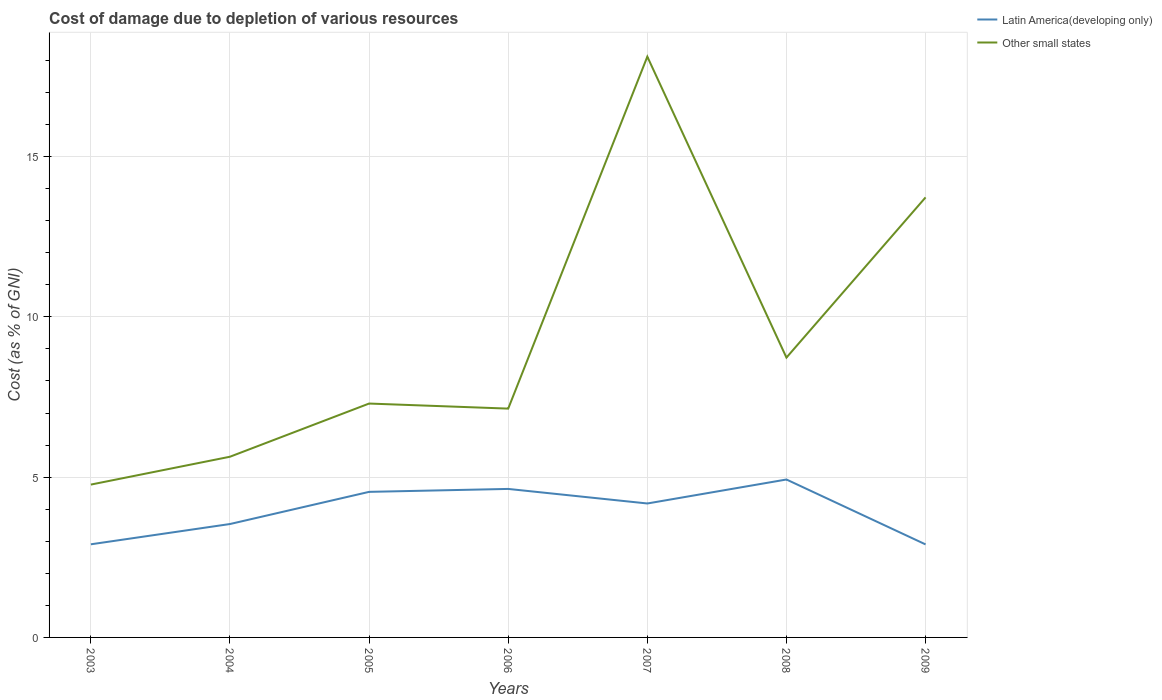Does the line corresponding to Latin America(developing only) intersect with the line corresponding to Other small states?
Make the answer very short. No. Across all years, what is the maximum cost of damage caused due to the depletion of various resources in Other small states?
Offer a very short reply. 4.77. What is the total cost of damage caused due to the depletion of various resources in Latin America(developing only) in the graph?
Provide a short and direct response. -0.63. What is the difference between the highest and the second highest cost of damage caused due to the depletion of various resources in Latin America(developing only)?
Offer a terse response. 2.02. What is the difference between the highest and the lowest cost of damage caused due to the depletion of various resources in Other small states?
Keep it short and to the point. 2. What is the difference between two consecutive major ticks on the Y-axis?
Give a very brief answer. 5. Are the values on the major ticks of Y-axis written in scientific E-notation?
Offer a very short reply. No. How many legend labels are there?
Ensure brevity in your answer.  2. How are the legend labels stacked?
Offer a very short reply. Vertical. What is the title of the graph?
Provide a succinct answer. Cost of damage due to depletion of various resources. Does "French Polynesia" appear as one of the legend labels in the graph?
Your answer should be compact. No. What is the label or title of the Y-axis?
Keep it short and to the point. Cost (as % of GNI). What is the Cost (as % of GNI) in Latin America(developing only) in 2003?
Your answer should be compact. 2.91. What is the Cost (as % of GNI) of Other small states in 2003?
Give a very brief answer. 4.77. What is the Cost (as % of GNI) in Latin America(developing only) in 2004?
Keep it short and to the point. 3.54. What is the Cost (as % of GNI) of Other small states in 2004?
Provide a short and direct response. 5.64. What is the Cost (as % of GNI) in Latin America(developing only) in 2005?
Your answer should be compact. 4.54. What is the Cost (as % of GNI) of Other small states in 2005?
Offer a very short reply. 7.3. What is the Cost (as % of GNI) in Latin America(developing only) in 2006?
Offer a terse response. 4.63. What is the Cost (as % of GNI) in Other small states in 2006?
Keep it short and to the point. 7.14. What is the Cost (as % of GNI) of Latin America(developing only) in 2007?
Give a very brief answer. 4.18. What is the Cost (as % of GNI) in Other small states in 2007?
Your response must be concise. 18.12. What is the Cost (as % of GNI) of Latin America(developing only) in 2008?
Offer a terse response. 4.93. What is the Cost (as % of GNI) in Other small states in 2008?
Your answer should be very brief. 8.73. What is the Cost (as % of GNI) in Latin America(developing only) in 2009?
Provide a succinct answer. 2.9. What is the Cost (as % of GNI) in Other small states in 2009?
Provide a short and direct response. 13.73. Across all years, what is the maximum Cost (as % of GNI) in Latin America(developing only)?
Provide a short and direct response. 4.93. Across all years, what is the maximum Cost (as % of GNI) of Other small states?
Offer a terse response. 18.12. Across all years, what is the minimum Cost (as % of GNI) of Latin America(developing only)?
Provide a short and direct response. 2.9. Across all years, what is the minimum Cost (as % of GNI) in Other small states?
Your answer should be very brief. 4.77. What is the total Cost (as % of GNI) of Latin America(developing only) in the graph?
Provide a succinct answer. 27.62. What is the total Cost (as % of GNI) in Other small states in the graph?
Offer a terse response. 65.41. What is the difference between the Cost (as % of GNI) of Latin America(developing only) in 2003 and that in 2004?
Give a very brief answer. -0.63. What is the difference between the Cost (as % of GNI) in Other small states in 2003 and that in 2004?
Provide a short and direct response. -0.87. What is the difference between the Cost (as % of GNI) of Latin America(developing only) in 2003 and that in 2005?
Keep it short and to the point. -1.64. What is the difference between the Cost (as % of GNI) in Other small states in 2003 and that in 2005?
Provide a succinct answer. -2.53. What is the difference between the Cost (as % of GNI) of Latin America(developing only) in 2003 and that in 2006?
Offer a terse response. -1.73. What is the difference between the Cost (as % of GNI) in Other small states in 2003 and that in 2006?
Provide a succinct answer. -2.37. What is the difference between the Cost (as % of GNI) of Latin America(developing only) in 2003 and that in 2007?
Provide a succinct answer. -1.27. What is the difference between the Cost (as % of GNI) of Other small states in 2003 and that in 2007?
Give a very brief answer. -13.35. What is the difference between the Cost (as % of GNI) in Latin America(developing only) in 2003 and that in 2008?
Make the answer very short. -2.02. What is the difference between the Cost (as % of GNI) of Other small states in 2003 and that in 2008?
Provide a succinct answer. -3.96. What is the difference between the Cost (as % of GNI) of Latin America(developing only) in 2003 and that in 2009?
Give a very brief answer. 0. What is the difference between the Cost (as % of GNI) in Other small states in 2003 and that in 2009?
Make the answer very short. -8.96. What is the difference between the Cost (as % of GNI) of Latin America(developing only) in 2004 and that in 2005?
Your answer should be very brief. -1. What is the difference between the Cost (as % of GNI) in Other small states in 2004 and that in 2005?
Give a very brief answer. -1.66. What is the difference between the Cost (as % of GNI) of Latin America(developing only) in 2004 and that in 2006?
Provide a short and direct response. -1.09. What is the difference between the Cost (as % of GNI) in Other small states in 2004 and that in 2006?
Your response must be concise. -1.5. What is the difference between the Cost (as % of GNI) of Latin America(developing only) in 2004 and that in 2007?
Ensure brevity in your answer.  -0.64. What is the difference between the Cost (as % of GNI) of Other small states in 2004 and that in 2007?
Your response must be concise. -12.48. What is the difference between the Cost (as % of GNI) of Latin America(developing only) in 2004 and that in 2008?
Provide a short and direct response. -1.39. What is the difference between the Cost (as % of GNI) of Other small states in 2004 and that in 2008?
Provide a short and direct response. -3.09. What is the difference between the Cost (as % of GNI) in Latin America(developing only) in 2004 and that in 2009?
Keep it short and to the point. 0.64. What is the difference between the Cost (as % of GNI) of Other small states in 2004 and that in 2009?
Provide a short and direct response. -8.09. What is the difference between the Cost (as % of GNI) in Latin America(developing only) in 2005 and that in 2006?
Provide a succinct answer. -0.09. What is the difference between the Cost (as % of GNI) of Other small states in 2005 and that in 2006?
Ensure brevity in your answer.  0.16. What is the difference between the Cost (as % of GNI) of Latin America(developing only) in 2005 and that in 2007?
Offer a terse response. 0.36. What is the difference between the Cost (as % of GNI) in Other small states in 2005 and that in 2007?
Your answer should be compact. -10.82. What is the difference between the Cost (as % of GNI) in Latin America(developing only) in 2005 and that in 2008?
Provide a succinct answer. -0.39. What is the difference between the Cost (as % of GNI) in Other small states in 2005 and that in 2008?
Your answer should be very brief. -1.43. What is the difference between the Cost (as % of GNI) of Latin America(developing only) in 2005 and that in 2009?
Give a very brief answer. 1.64. What is the difference between the Cost (as % of GNI) of Other small states in 2005 and that in 2009?
Provide a short and direct response. -6.43. What is the difference between the Cost (as % of GNI) of Latin America(developing only) in 2006 and that in 2007?
Give a very brief answer. 0.45. What is the difference between the Cost (as % of GNI) of Other small states in 2006 and that in 2007?
Make the answer very short. -10.98. What is the difference between the Cost (as % of GNI) in Latin America(developing only) in 2006 and that in 2008?
Offer a very short reply. -0.29. What is the difference between the Cost (as % of GNI) of Other small states in 2006 and that in 2008?
Offer a terse response. -1.59. What is the difference between the Cost (as % of GNI) of Latin America(developing only) in 2006 and that in 2009?
Give a very brief answer. 1.73. What is the difference between the Cost (as % of GNI) of Other small states in 2006 and that in 2009?
Give a very brief answer. -6.59. What is the difference between the Cost (as % of GNI) of Latin America(developing only) in 2007 and that in 2008?
Your answer should be compact. -0.75. What is the difference between the Cost (as % of GNI) in Other small states in 2007 and that in 2008?
Give a very brief answer. 9.39. What is the difference between the Cost (as % of GNI) of Latin America(developing only) in 2007 and that in 2009?
Make the answer very short. 1.28. What is the difference between the Cost (as % of GNI) in Other small states in 2007 and that in 2009?
Provide a succinct answer. 4.39. What is the difference between the Cost (as % of GNI) of Latin America(developing only) in 2008 and that in 2009?
Provide a short and direct response. 2.02. What is the difference between the Cost (as % of GNI) of Other small states in 2008 and that in 2009?
Provide a succinct answer. -5. What is the difference between the Cost (as % of GNI) of Latin America(developing only) in 2003 and the Cost (as % of GNI) of Other small states in 2004?
Provide a succinct answer. -2.73. What is the difference between the Cost (as % of GNI) in Latin America(developing only) in 2003 and the Cost (as % of GNI) in Other small states in 2005?
Your answer should be very brief. -4.39. What is the difference between the Cost (as % of GNI) in Latin America(developing only) in 2003 and the Cost (as % of GNI) in Other small states in 2006?
Ensure brevity in your answer.  -4.23. What is the difference between the Cost (as % of GNI) of Latin America(developing only) in 2003 and the Cost (as % of GNI) of Other small states in 2007?
Your answer should be very brief. -15.21. What is the difference between the Cost (as % of GNI) in Latin America(developing only) in 2003 and the Cost (as % of GNI) in Other small states in 2008?
Give a very brief answer. -5.82. What is the difference between the Cost (as % of GNI) in Latin America(developing only) in 2003 and the Cost (as % of GNI) in Other small states in 2009?
Offer a very short reply. -10.82. What is the difference between the Cost (as % of GNI) of Latin America(developing only) in 2004 and the Cost (as % of GNI) of Other small states in 2005?
Offer a very short reply. -3.76. What is the difference between the Cost (as % of GNI) of Latin America(developing only) in 2004 and the Cost (as % of GNI) of Other small states in 2006?
Provide a succinct answer. -3.6. What is the difference between the Cost (as % of GNI) in Latin America(developing only) in 2004 and the Cost (as % of GNI) in Other small states in 2007?
Keep it short and to the point. -14.58. What is the difference between the Cost (as % of GNI) in Latin America(developing only) in 2004 and the Cost (as % of GNI) in Other small states in 2008?
Provide a short and direct response. -5.19. What is the difference between the Cost (as % of GNI) of Latin America(developing only) in 2004 and the Cost (as % of GNI) of Other small states in 2009?
Your answer should be compact. -10.19. What is the difference between the Cost (as % of GNI) of Latin America(developing only) in 2005 and the Cost (as % of GNI) of Other small states in 2006?
Provide a short and direct response. -2.6. What is the difference between the Cost (as % of GNI) in Latin America(developing only) in 2005 and the Cost (as % of GNI) in Other small states in 2007?
Make the answer very short. -13.58. What is the difference between the Cost (as % of GNI) in Latin America(developing only) in 2005 and the Cost (as % of GNI) in Other small states in 2008?
Your answer should be very brief. -4.19. What is the difference between the Cost (as % of GNI) in Latin America(developing only) in 2005 and the Cost (as % of GNI) in Other small states in 2009?
Ensure brevity in your answer.  -9.19. What is the difference between the Cost (as % of GNI) of Latin America(developing only) in 2006 and the Cost (as % of GNI) of Other small states in 2007?
Make the answer very short. -13.49. What is the difference between the Cost (as % of GNI) of Latin America(developing only) in 2006 and the Cost (as % of GNI) of Other small states in 2008?
Your answer should be compact. -4.1. What is the difference between the Cost (as % of GNI) in Latin America(developing only) in 2006 and the Cost (as % of GNI) in Other small states in 2009?
Ensure brevity in your answer.  -9.09. What is the difference between the Cost (as % of GNI) of Latin America(developing only) in 2007 and the Cost (as % of GNI) of Other small states in 2008?
Offer a very short reply. -4.55. What is the difference between the Cost (as % of GNI) of Latin America(developing only) in 2007 and the Cost (as % of GNI) of Other small states in 2009?
Give a very brief answer. -9.55. What is the difference between the Cost (as % of GNI) of Latin America(developing only) in 2008 and the Cost (as % of GNI) of Other small states in 2009?
Provide a succinct answer. -8.8. What is the average Cost (as % of GNI) of Latin America(developing only) per year?
Your response must be concise. 3.95. What is the average Cost (as % of GNI) in Other small states per year?
Your answer should be very brief. 9.34. In the year 2003, what is the difference between the Cost (as % of GNI) of Latin America(developing only) and Cost (as % of GNI) of Other small states?
Provide a succinct answer. -1.86. In the year 2004, what is the difference between the Cost (as % of GNI) in Latin America(developing only) and Cost (as % of GNI) in Other small states?
Ensure brevity in your answer.  -2.1. In the year 2005, what is the difference between the Cost (as % of GNI) in Latin America(developing only) and Cost (as % of GNI) in Other small states?
Provide a succinct answer. -2.76. In the year 2006, what is the difference between the Cost (as % of GNI) in Latin America(developing only) and Cost (as % of GNI) in Other small states?
Your answer should be very brief. -2.51. In the year 2007, what is the difference between the Cost (as % of GNI) of Latin America(developing only) and Cost (as % of GNI) of Other small states?
Your answer should be compact. -13.94. In the year 2008, what is the difference between the Cost (as % of GNI) of Latin America(developing only) and Cost (as % of GNI) of Other small states?
Your answer should be compact. -3.8. In the year 2009, what is the difference between the Cost (as % of GNI) of Latin America(developing only) and Cost (as % of GNI) of Other small states?
Your answer should be very brief. -10.83. What is the ratio of the Cost (as % of GNI) in Latin America(developing only) in 2003 to that in 2004?
Provide a short and direct response. 0.82. What is the ratio of the Cost (as % of GNI) in Other small states in 2003 to that in 2004?
Ensure brevity in your answer.  0.85. What is the ratio of the Cost (as % of GNI) in Latin America(developing only) in 2003 to that in 2005?
Offer a very short reply. 0.64. What is the ratio of the Cost (as % of GNI) of Other small states in 2003 to that in 2005?
Provide a short and direct response. 0.65. What is the ratio of the Cost (as % of GNI) of Latin America(developing only) in 2003 to that in 2006?
Offer a terse response. 0.63. What is the ratio of the Cost (as % of GNI) in Other small states in 2003 to that in 2006?
Make the answer very short. 0.67. What is the ratio of the Cost (as % of GNI) of Latin America(developing only) in 2003 to that in 2007?
Your response must be concise. 0.7. What is the ratio of the Cost (as % of GNI) in Other small states in 2003 to that in 2007?
Offer a terse response. 0.26. What is the ratio of the Cost (as % of GNI) of Latin America(developing only) in 2003 to that in 2008?
Provide a succinct answer. 0.59. What is the ratio of the Cost (as % of GNI) in Other small states in 2003 to that in 2008?
Provide a succinct answer. 0.55. What is the ratio of the Cost (as % of GNI) in Latin America(developing only) in 2003 to that in 2009?
Your answer should be compact. 1. What is the ratio of the Cost (as % of GNI) in Other small states in 2003 to that in 2009?
Provide a short and direct response. 0.35. What is the ratio of the Cost (as % of GNI) in Latin America(developing only) in 2004 to that in 2005?
Offer a very short reply. 0.78. What is the ratio of the Cost (as % of GNI) in Other small states in 2004 to that in 2005?
Ensure brevity in your answer.  0.77. What is the ratio of the Cost (as % of GNI) of Latin America(developing only) in 2004 to that in 2006?
Your answer should be compact. 0.76. What is the ratio of the Cost (as % of GNI) of Other small states in 2004 to that in 2006?
Your response must be concise. 0.79. What is the ratio of the Cost (as % of GNI) in Latin America(developing only) in 2004 to that in 2007?
Offer a very short reply. 0.85. What is the ratio of the Cost (as % of GNI) of Other small states in 2004 to that in 2007?
Your response must be concise. 0.31. What is the ratio of the Cost (as % of GNI) of Latin America(developing only) in 2004 to that in 2008?
Your answer should be very brief. 0.72. What is the ratio of the Cost (as % of GNI) in Other small states in 2004 to that in 2008?
Give a very brief answer. 0.65. What is the ratio of the Cost (as % of GNI) in Latin America(developing only) in 2004 to that in 2009?
Give a very brief answer. 1.22. What is the ratio of the Cost (as % of GNI) of Other small states in 2004 to that in 2009?
Give a very brief answer. 0.41. What is the ratio of the Cost (as % of GNI) of Latin America(developing only) in 2005 to that in 2006?
Keep it short and to the point. 0.98. What is the ratio of the Cost (as % of GNI) in Other small states in 2005 to that in 2006?
Provide a short and direct response. 1.02. What is the ratio of the Cost (as % of GNI) of Latin America(developing only) in 2005 to that in 2007?
Provide a succinct answer. 1.09. What is the ratio of the Cost (as % of GNI) in Other small states in 2005 to that in 2007?
Your answer should be compact. 0.4. What is the ratio of the Cost (as % of GNI) in Latin America(developing only) in 2005 to that in 2008?
Your response must be concise. 0.92. What is the ratio of the Cost (as % of GNI) of Other small states in 2005 to that in 2008?
Give a very brief answer. 0.84. What is the ratio of the Cost (as % of GNI) in Latin America(developing only) in 2005 to that in 2009?
Make the answer very short. 1.56. What is the ratio of the Cost (as % of GNI) of Other small states in 2005 to that in 2009?
Provide a succinct answer. 0.53. What is the ratio of the Cost (as % of GNI) of Latin America(developing only) in 2006 to that in 2007?
Your response must be concise. 1.11. What is the ratio of the Cost (as % of GNI) in Other small states in 2006 to that in 2007?
Keep it short and to the point. 0.39. What is the ratio of the Cost (as % of GNI) in Latin America(developing only) in 2006 to that in 2008?
Offer a terse response. 0.94. What is the ratio of the Cost (as % of GNI) in Other small states in 2006 to that in 2008?
Provide a succinct answer. 0.82. What is the ratio of the Cost (as % of GNI) of Latin America(developing only) in 2006 to that in 2009?
Your answer should be compact. 1.6. What is the ratio of the Cost (as % of GNI) in Other small states in 2006 to that in 2009?
Offer a very short reply. 0.52. What is the ratio of the Cost (as % of GNI) of Latin America(developing only) in 2007 to that in 2008?
Ensure brevity in your answer.  0.85. What is the ratio of the Cost (as % of GNI) in Other small states in 2007 to that in 2008?
Provide a succinct answer. 2.08. What is the ratio of the Cost (as % of GNI) in Latin America(developing only) in 2007 to that in 2009?
Your answer should be compact. 1.44. What is the ratio of the Cost (as % of GNI) of Other small states in 2007 to that in 2009?
Your answer should be compact. 1.32. What is the ratio of the Cost (as % of GNI) in Latin America(developing only) in 2008 to that in 2009?
Provide a short and direct response. 1.7. What is the ratio of the Cost (as % of GNI) in Other small states in 2008 to that in 2009?
Keep it short and to the point. 0.64. What is the difference between the highest and the second highest Cost (as % of GNI) in Latin America(developing only)?
Your response must be concise. 0.29. What is the difference between the highest and the second highest Cost (as % of GNI) of Other small states?
Ensure brevity in your answer.  4.39. What is the difference between the highest and the lowest Cost (as % of GNI) of Latin America(developing only)?
Offer a terse response. 2.02. What is the difference between the highest and the lowest Cost (as % of GNI) in Other small states?
Your answer should be very brief. 13.35. 